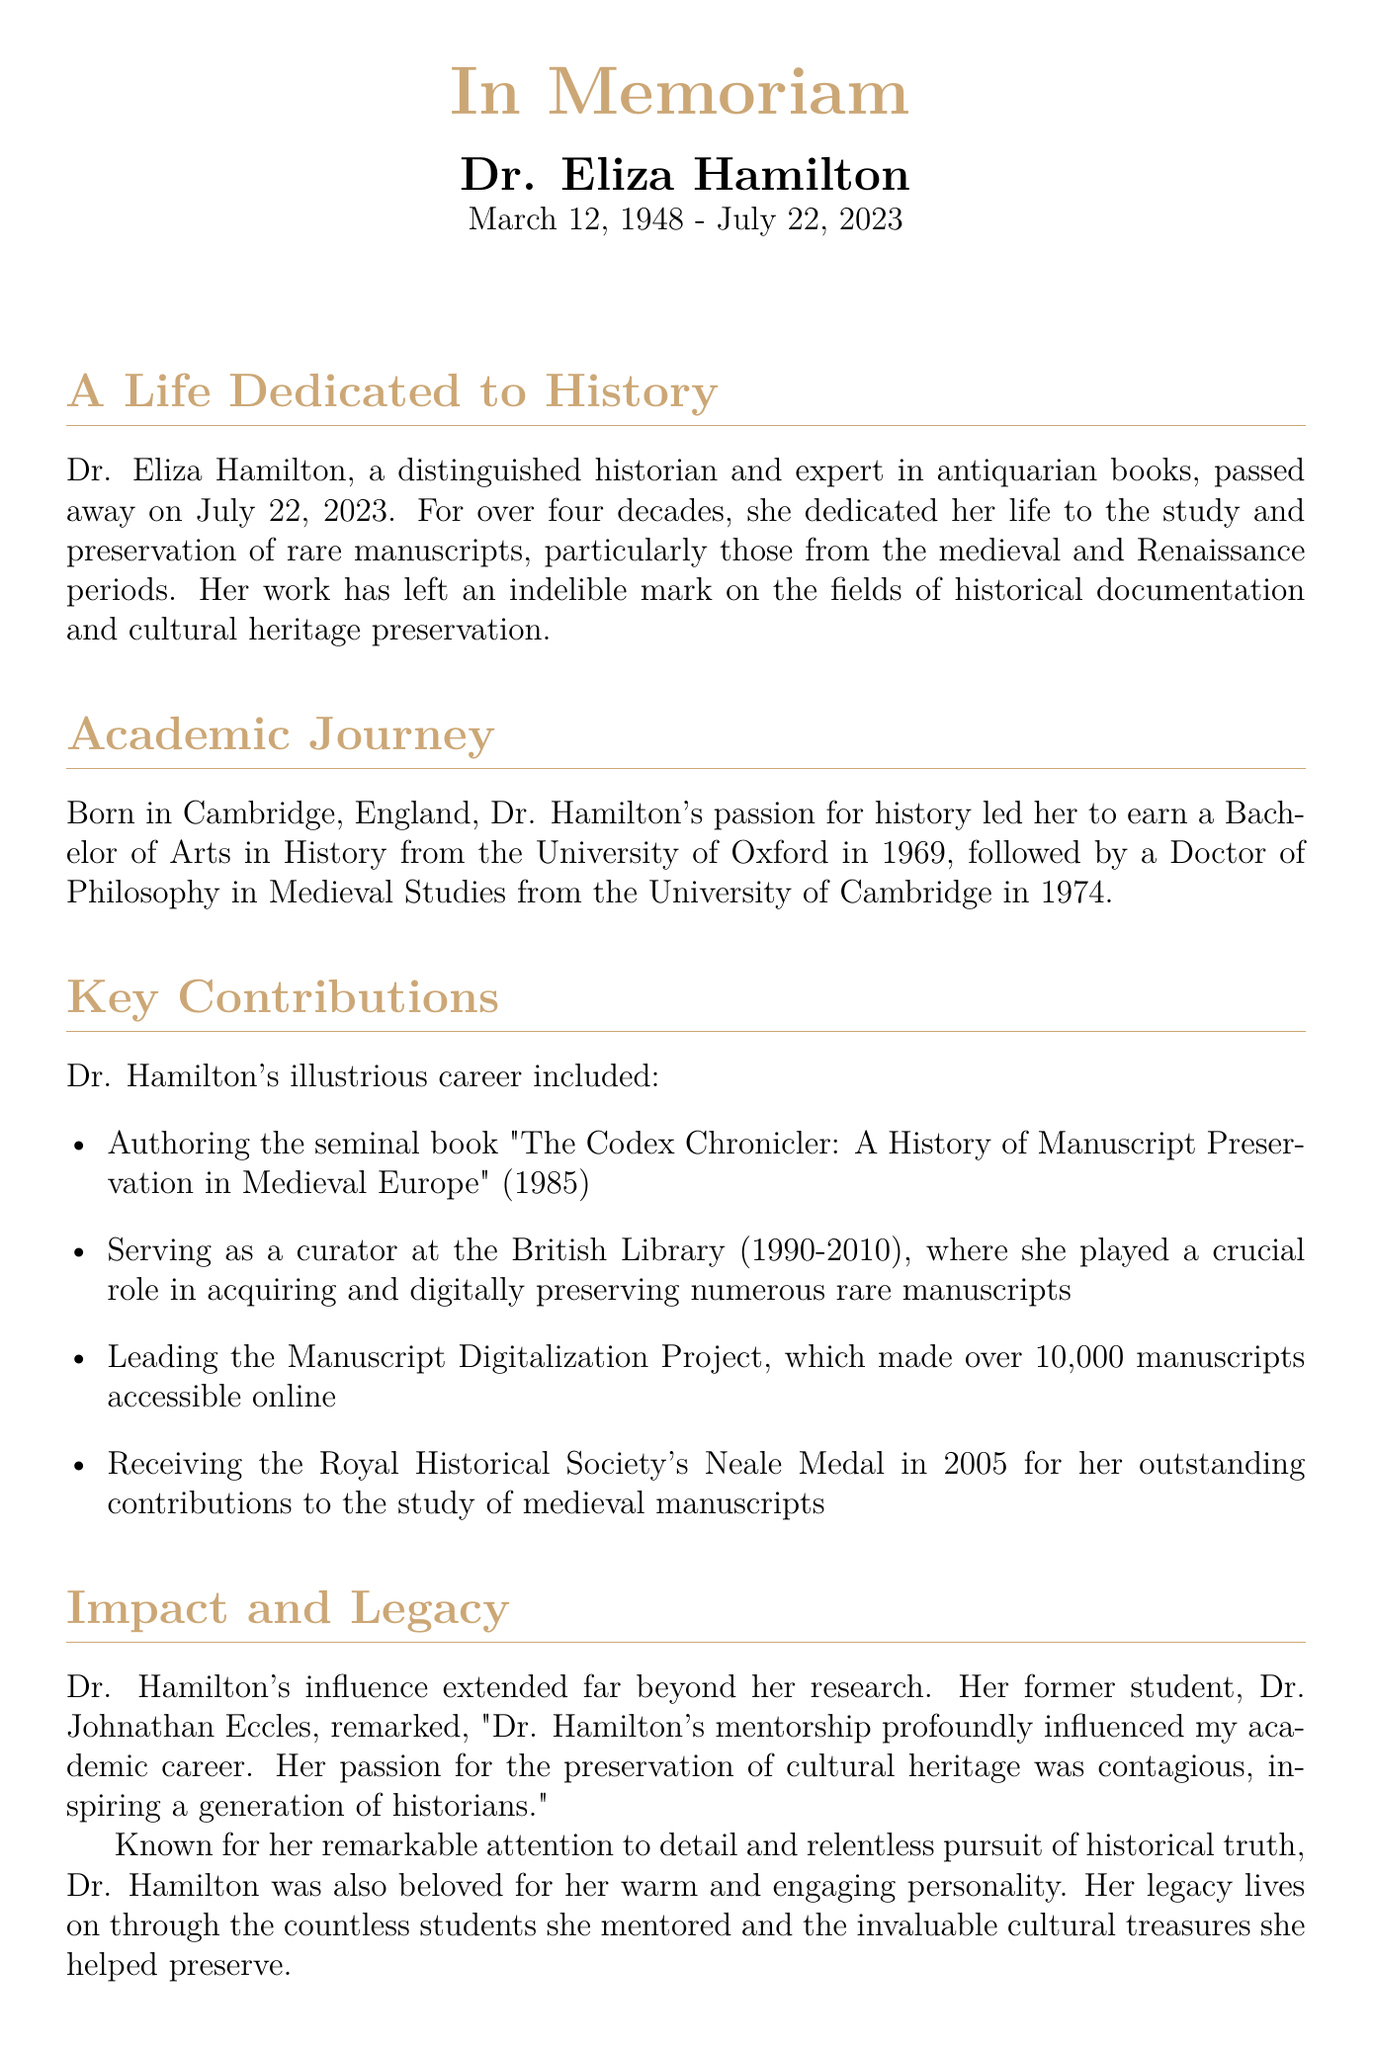What was Dr. Eliza Hamilton's date of birth? The document states that Dr. Eliza Hamilton was born on March 12, 1948.
Answer: March 12, 1948 What year did Dr. Hamilton pass away? The document mentions that Dr. Hamilton passed away on July 22, 2023.
Answer: July 22, 2023 What is the title of Dr. Hamilton's seminal book? The document lists her book as "The Codex Chronicler: A History of Manuscript Preservation in Medieval Europe".
Answer: The Codex Chronicler: A History of Manuscript Preservation in Medieval Europe Which prestigious award did Dr. Hamilton receive in 2005? The document states that she received the Royal Historical Society's Neale Medal in that year.
Answer: Neale Medal What role did Dr. Hamilton serve at the British Library? According to the document, she served as a curator at the British Library.
Answer: Curator In which university did Dr. Hamilton complete her Doctor of Philosophy? The document indicates that she completed her PhD at the University of Cambridge.
Answer: University of Cambridge Who remarked about Dr. Hamilton's influence? The document identifies Dr. Johnathan Eccles as the person who remarked on her influence.
Answer: Dr. Johnathan Eccles What was the focus of Dr. Hamilton's professional dedication? The document highlights that her focus was on the study and preservation of rare manuscripts.
Answer: Rare manuscripts How many manuscripts were made accessible online through the Manuscript Digitalization Project? The document states that over 10,000 manuscripts were made accessible online.
Answer: Over 10,000 manuscripts 